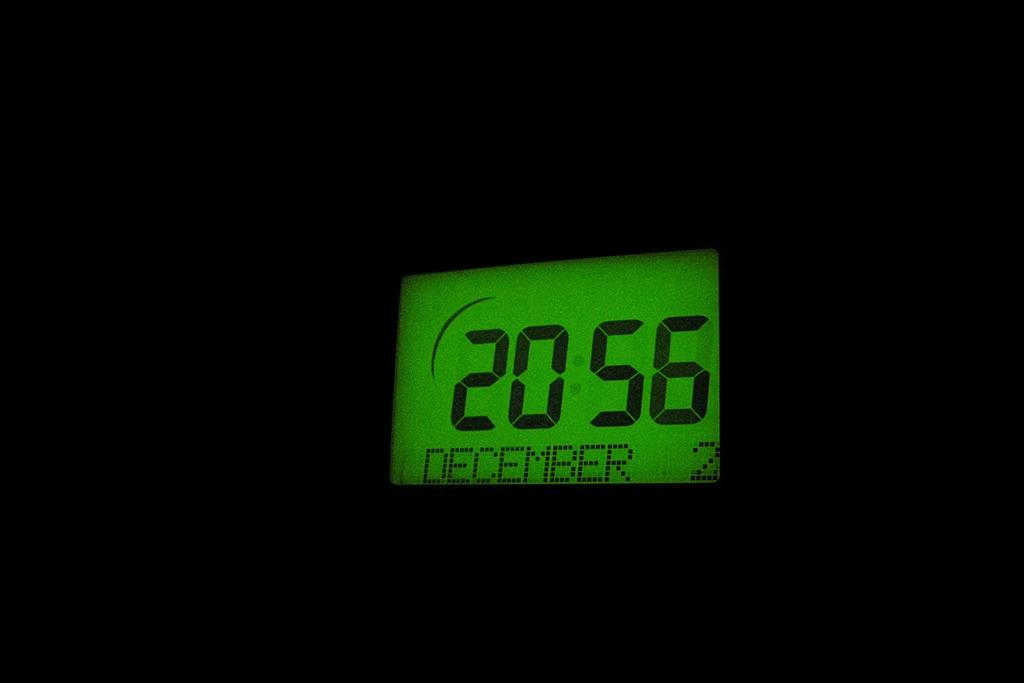<image>
Write a terse but informative summary of the picture. An electronic clock that says that is December. 